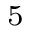Convert formula to latex. <formula><loc_0><loc_0><loc_500><loc_500>^ { 5 }</formula> 